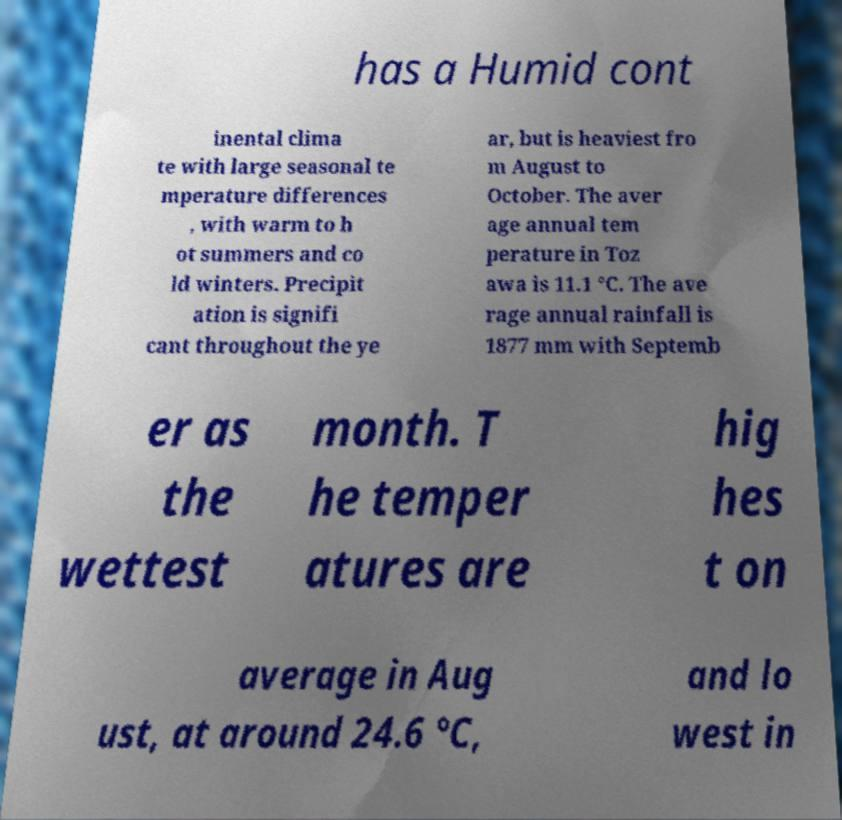Please read and relay the text visible in this image. What does it say? has a Humid cont inental clima te with large seasonal te mperature differences , with warm to h ot summers and co ld winters. Precipit ation is signifi cant throughout the ye ar, but is heaviest fro m August to October. The aver age annual tem perature in Toz awa is 11.1 °C. The ave rage annual rainfall is 1877 mm with Septemb er as the wettest month. T he temper atures are hig hes t on average in Aug ust, at around 24.6 °C, and lo west in 